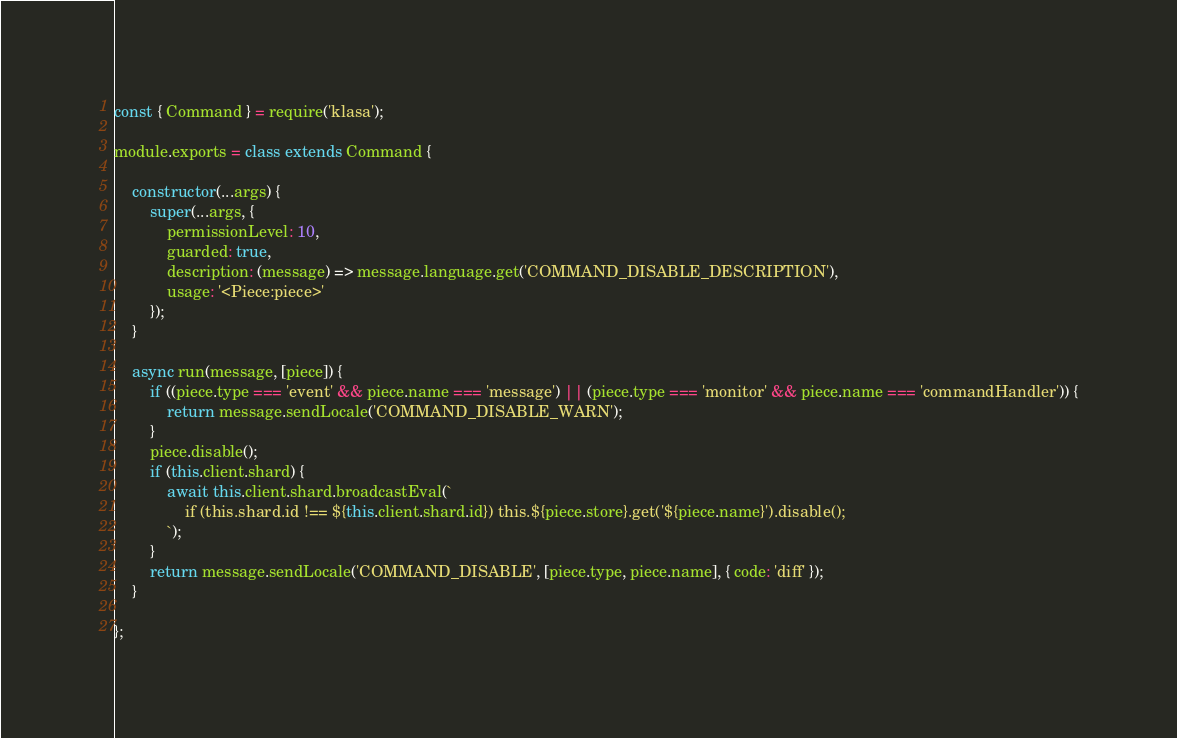Convert code to text. <code><loc_0><loc_0><loc_500><loc_500><_JavaScript_>const { Command } = require('klasa');

module.exports = class extends Command {

	constructor(...args) {
		super(...args, {
			permissionLevel: 10,
			guarded: true,
			description: (message) => message.language.get('COMMAND_DISABLE_DESCRIPTION'),
			usage: '<Piece:piece>'
		});
	}

	async run(message, [piece]) {
		if ((piece.type === 'event' && piece.name === 'message') || (piece.type === 'monitor' && piece.name === 'commandHandler')) {
			return message.sendLocale('COMMAND_DISABLE_WARN');
		}
		piece.disable();
		if (this.client.shard) {
			await this.client.shard.broadcastEval(`
				if (this.shard.id !== ${this.client.shard.id}) this.${piece.store}.get('${piece.name}').disable();
			`);
		}
		return message.sendLocale('COMMAND_DISABLE', [piece.type, piece.name], { code: 'diff' });
	}

};
</code> 